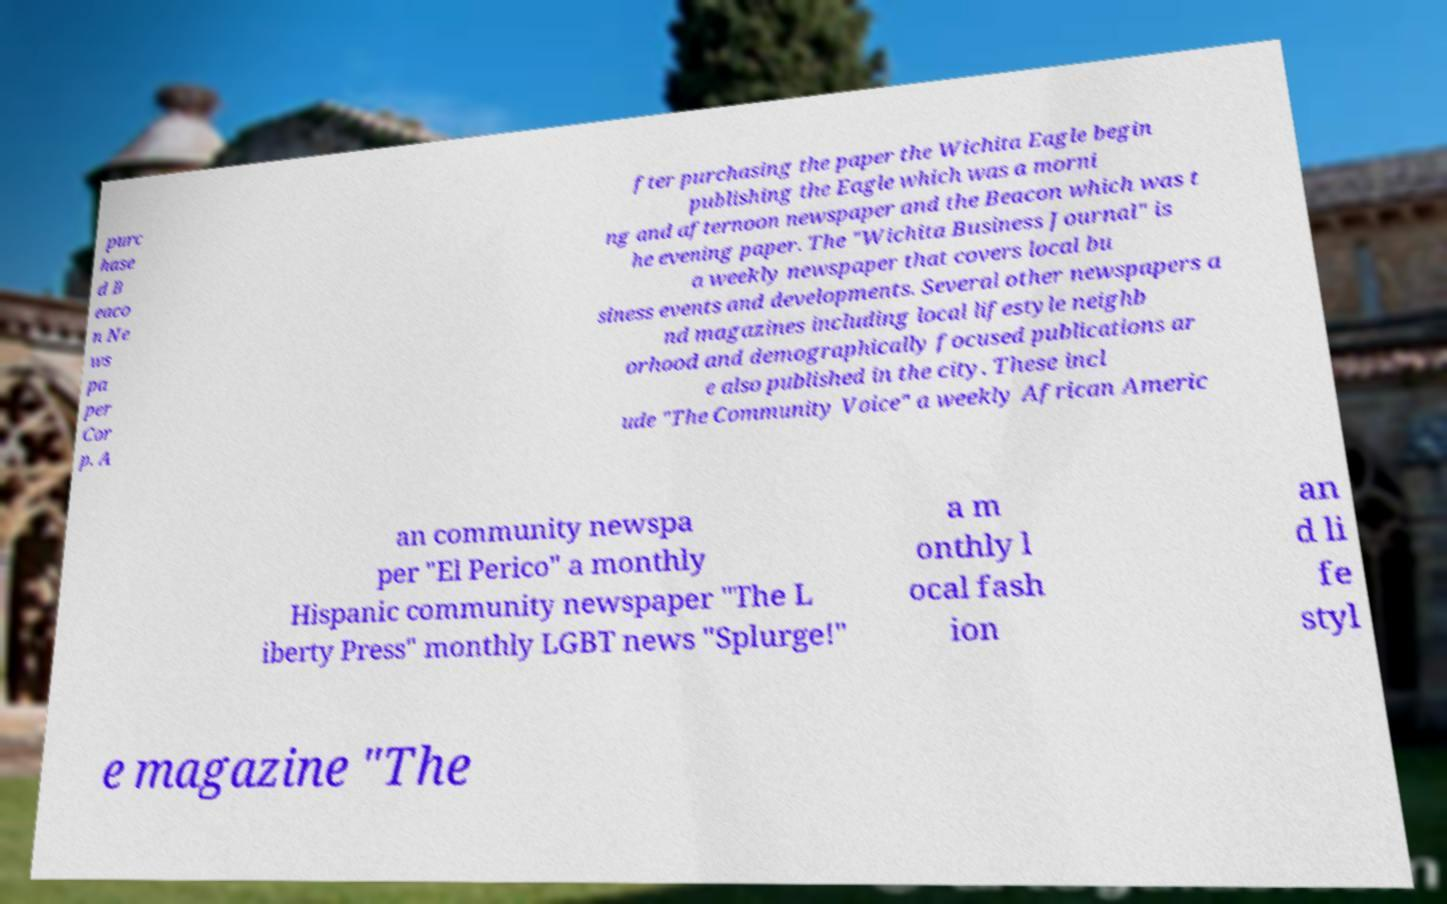Can you read and provide the text displayed in the image?This photo seems to have some interesting text. Can you extract and type it out for me? purc hase d B eaco n Ne ws pa per Cor p. A fter purchasing the paper the Wichita Eagle begin publishing the Eagle which was a morni ng and afternoon newspaper and the Beacon which was t he evening paper. The "Wichita Business Journal" is a weekly newspaper that covers local bu siness events and developments. Several other newspapers a nd magazines including local lifestyle neighb orhood and demographically focused publications ar e also published in the city. These incl ude "The Community Voice" a weekly African Americ an community newspa per "El Perico" a monthly Hispanic community newspaper "The L iberty Press" monthly LGBT news "Splurge!" a m onthly l ocal fash ion an d li fe styl e magazine "The 